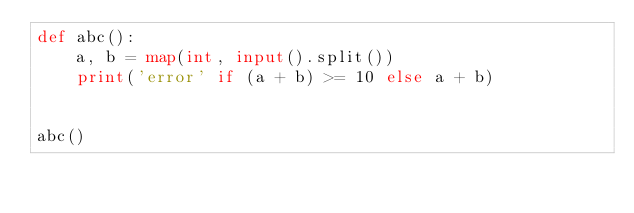Convert code to text. <code><loc_0><loc_0><loc_500><loc_500><_Python_>def abc():
    a, b = map(int, input().split())
    print('error' if (a + b) >= 10 else a + b)


abc()
</code> 